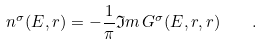<formula> <loc_0><loc_0><loc_500><loc_500>n ^ { \sigma } ( E , { r } ) = - \frac { 1 } { \pi } { \mathfrak I m } \, G ^ { \sigma } ( E , { r } , { r } ) \quad .</formula> 